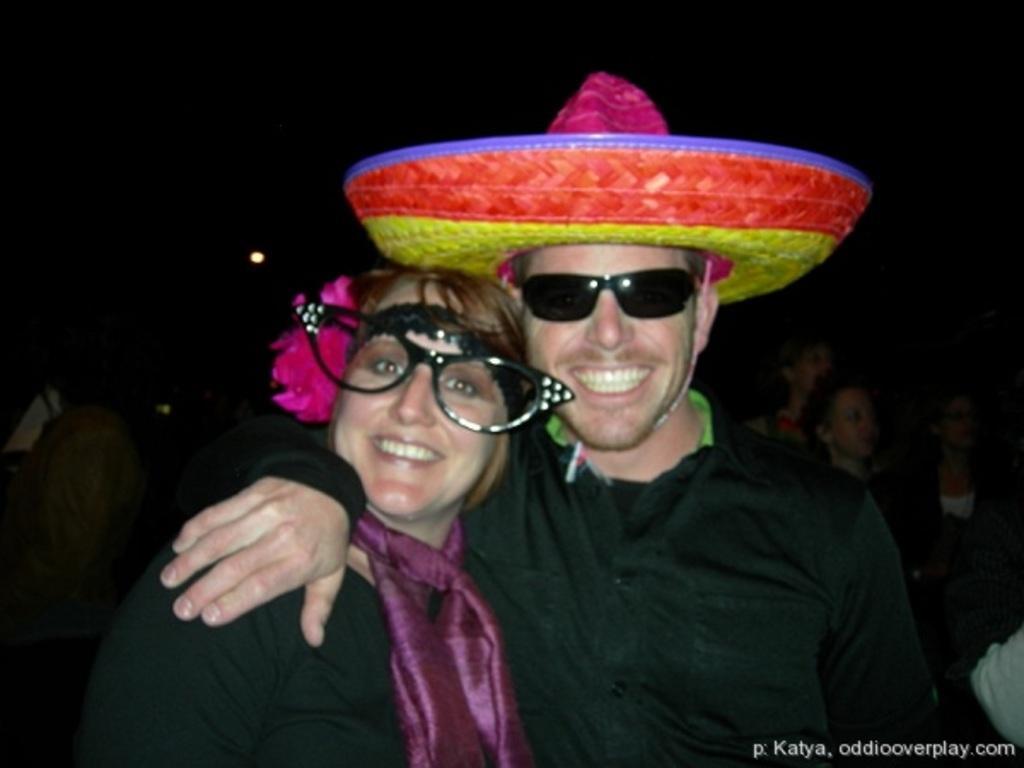Describe this image in one or two sentences. In foreground we can see two person a lady and a men and both are wearing black color shirt and spectacles. That lady wearing pink color scarf and men wearing a hat which have four colors pink, red, yellow and violet. In background we can see some ladies standing over there. 